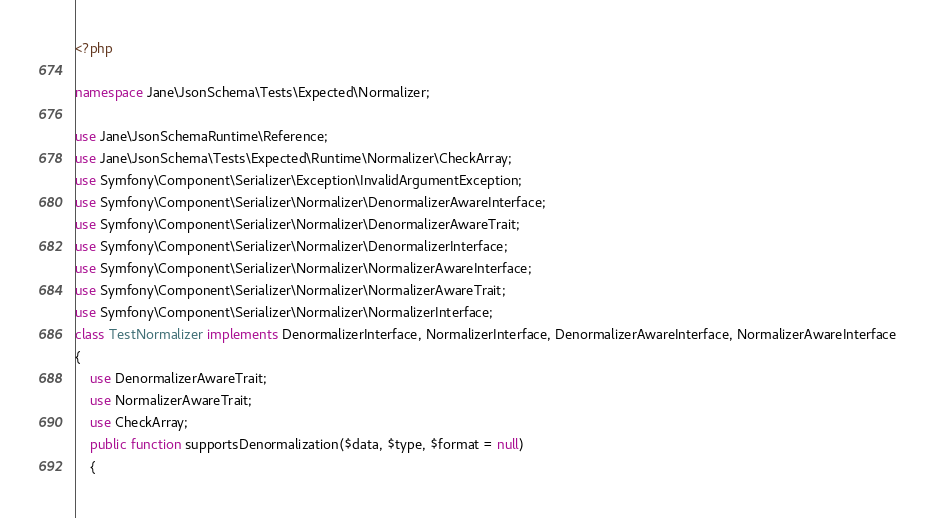<code> <loc_0><loc_0><loc_500><loc_500><_PHP_><?php

namespace Jane\JsonSchema\Tests\Expected\Normalizer;

use Jane\JsonSchemaRuntime\Reference;
use Jane\JsonSchema\Tests\Expected\Runtime\Normalizer\CheckArray;
use Symfony\Component\Serializer\Exception\InvalidArgumentException;
use Symfony\Component\Serializer\Normalizer\DenormalizerAwareInterface;
use Symfony\Component\Serializer\Normalizer\DenormalizerAwareTrait;
use Symfony\Component\Serializer\Normalizer\DenormalizerInterface;
use Symfony\Component\Serializer\Normalizer\NormalizerAwareInterface;
use Symfony\Component\Serializer\Normalizer\NormalizerAwareTrait;
use Symfony\Component\Serializer\Normalizer\NormalizerInterface;
class TestNormalizer implements DenormalizerInterface, NormalizerInterface, DenormalizerAwareInterface, NormalizerAwareInterface
{
    use DenormalizerAwareTrait;
    use NormalizerAwareTrait;
    use CheckArray;
    public function supportsDenormalization($data, $type, $format = null)
    {</code> 